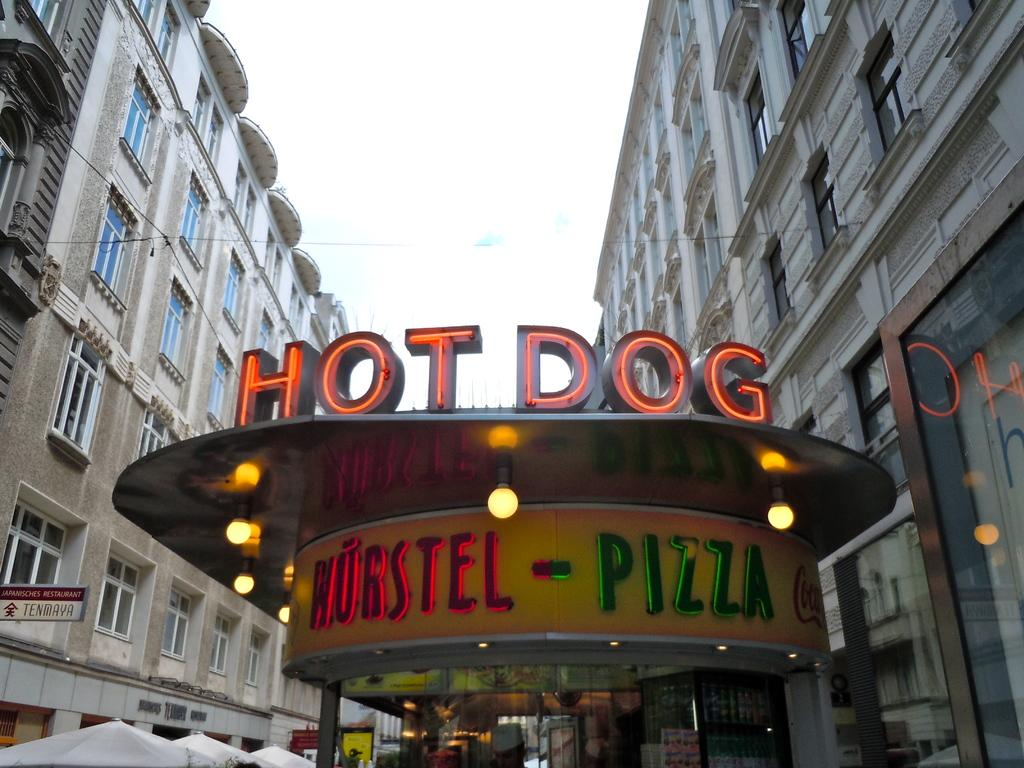What type of structures can be seen in the image? There are buildings in the image. Can you describe the store located in the image? There is a store at the bottom of the image. What can be seen illuminated in the image? Lights are visible in the image. What is visible in the background of the image? There is sky visible in the background of the image. What type of temporary shelters are on the left side of the image? There are tents on the left side of the image. What type of throat medicine is advertised on the store's sign in the image? There is no throat medicine or any advertisement mentioned in the image; it only features buildings, a store, lights, sky, and tents. 